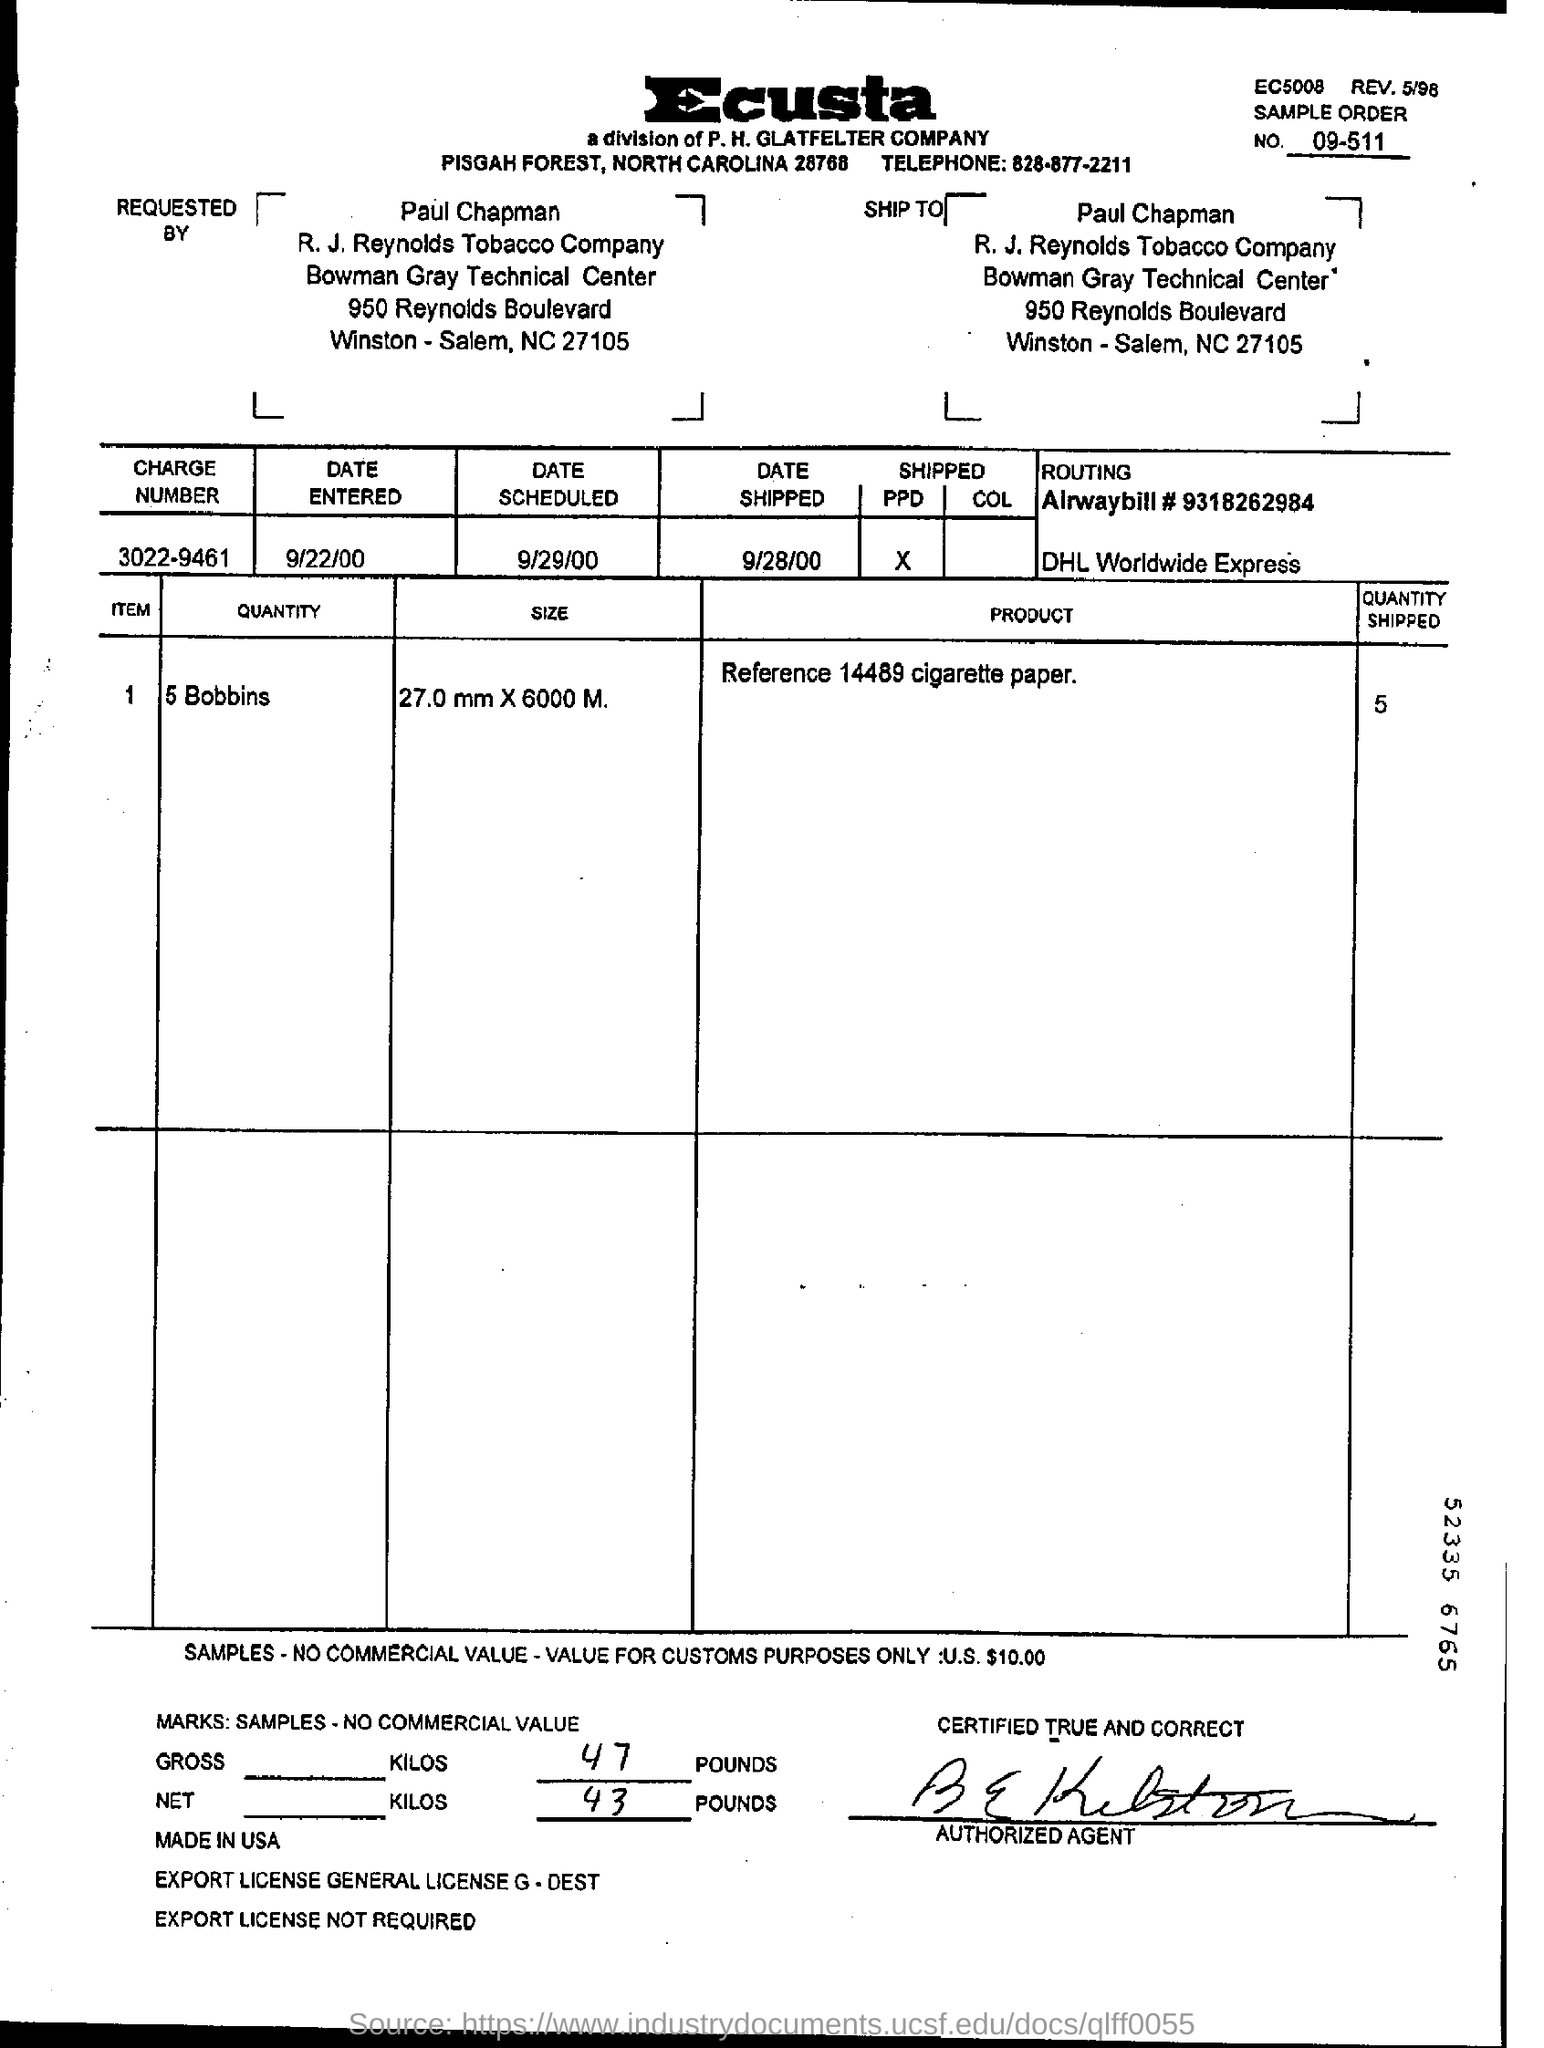What is the sample order no mentioned in the document?
Offer a very short reply. 09-511. Who has requested this order?
Ensure brevity in your answer.  Paul Chapman. What is the charge number given?
Ensure brevity in your answer.  3022-9461. What is the size (dimensions) of the bobbins?
Offer a very short reply. 27.0 mm ×  6000 M. What is the product  mentioned in the document?
Make the answer very short. Reference 14489 cigarette paper. What is the quantity shipped?
Offer a very short reply. 5. What is the Date Shipped as per the document?
Provide a succinct answer. 9/28/00. 